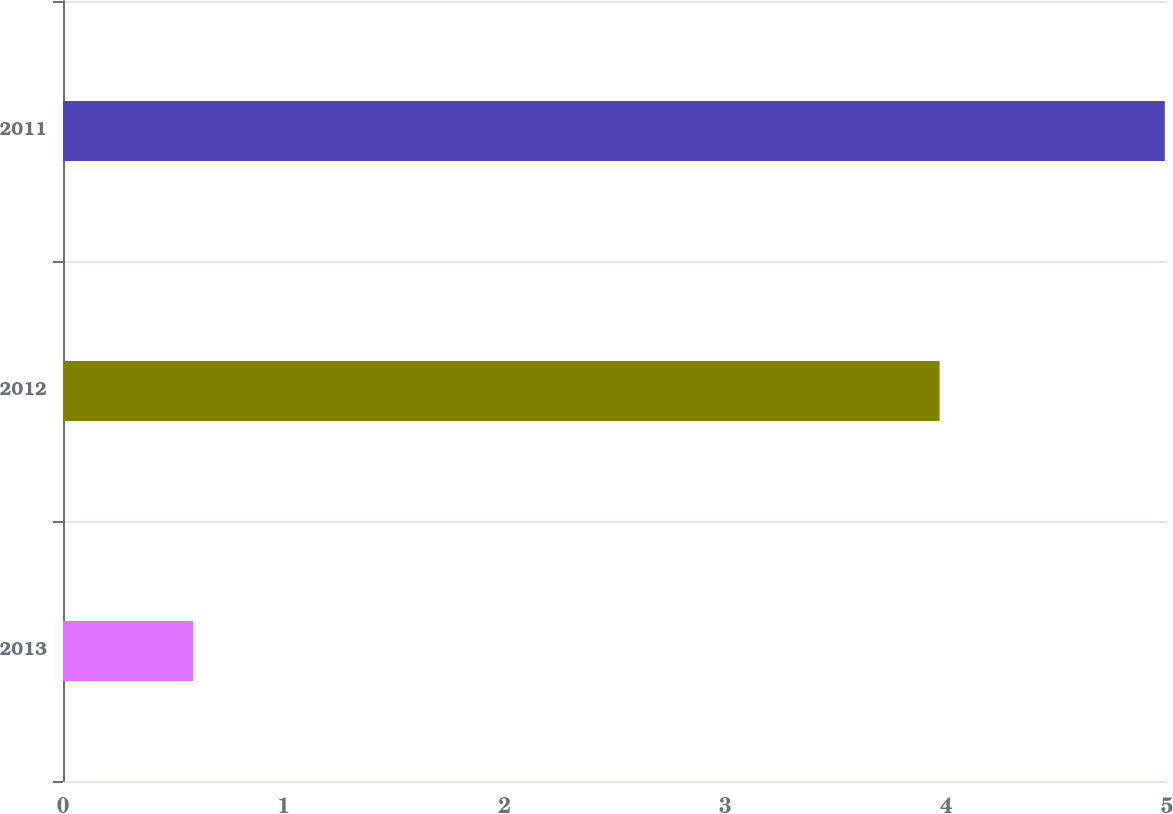<chart> <loc_0><loc_0><loc_500><loc_500><bar_chart><fcel>2013<fcel>2012<fcel>2011<nl><fcel>0.59<fcel>3.97<fcel>4.99<nl></chart> 